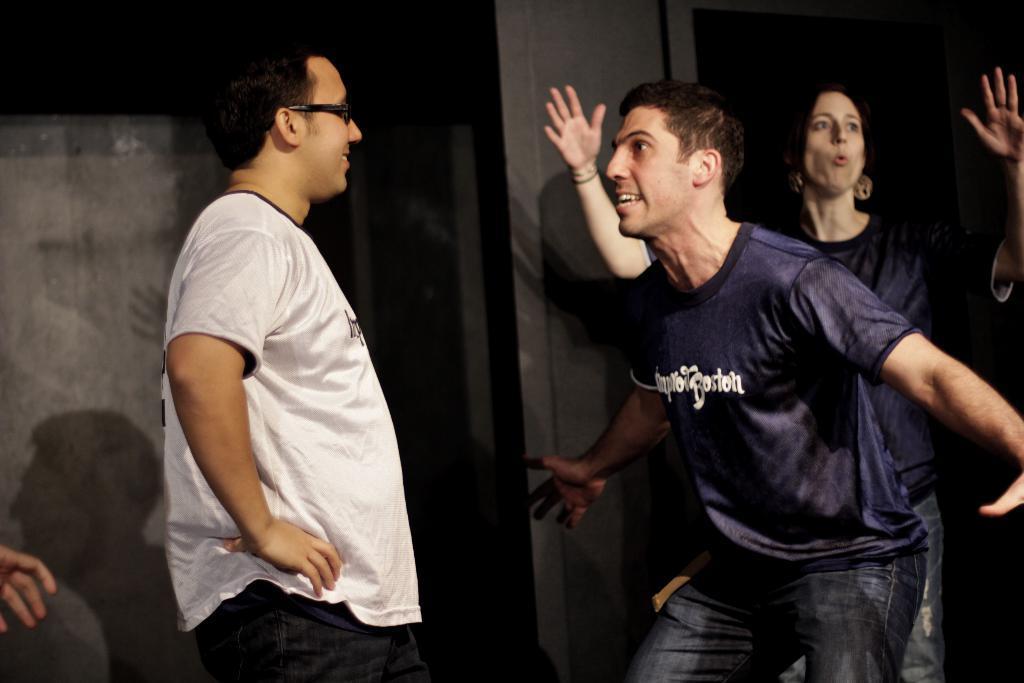Please provide a concise description of this image. In this image there are two men and a woman, in the background there is a wall. 